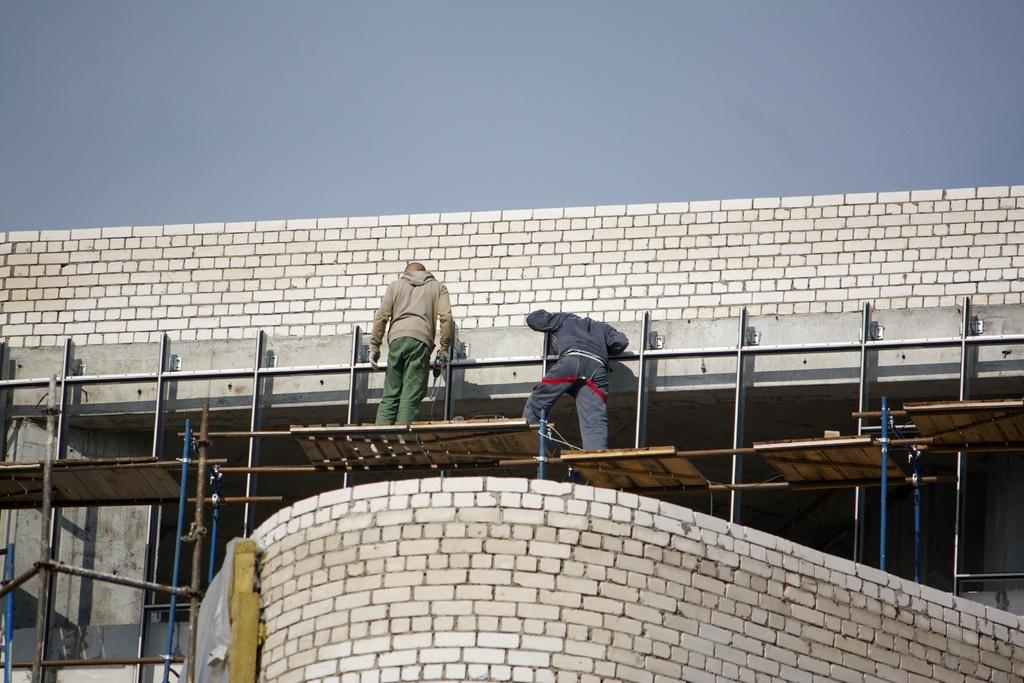How many people are in the image? There are two persons in the image. What are the persons doing in the image? The persons are standing beside a bridge. Can you describe the bridge in the image? The bridge has a support above a wall. What is visible in the background of the image? The sky is visible in the image. What type of steel is used to construct the fork visible in the image? There is no fork present in the image. Can you describe the tail of the animal in the image? There is no animal with a tail present in the image. 